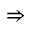<formula> <loc_0><loc_0><loc_500><loc_500>\Rightarrow</formula> 